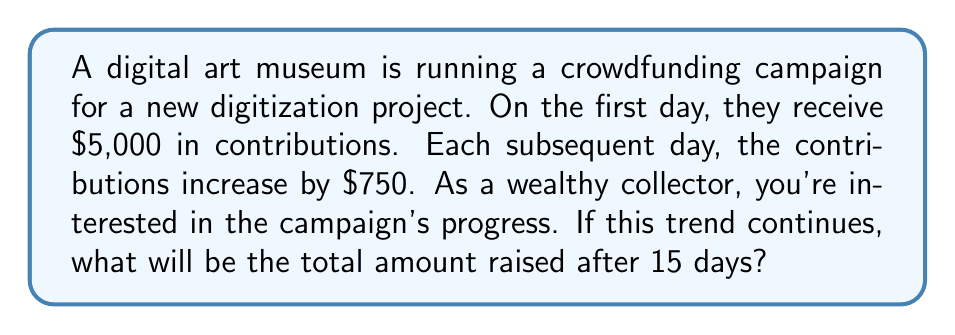Teach me how to tackle this problem. Let's approach this step-by-step using an arithmetic sequence:

1) We have an arithmetic sequence where:
   $a_1 = 5000$ (first term)
   $d = 750$ (common difference)
   $n = 15$ (number of terms)

2) We need to find the sum of this arithmetic sequence. The formula for the sum of an arithmetic sequence is:

   $$S_n = \frac{n}{2}(a_1 + a_n)$$

   Where $a_n$ is the last term.

3) To find $a_n$, we use the formula:
   $$a_n = a_1 + (n-1)d$$
   $$a_{15} = 5000 + (15-1)750 = 5000 + 10500 = 15500$$

4) Now we can calculate the sum:

   $$S_{15} = \frac{15}{2}(5000 + 15500)$$
   $$S_{15} = \frac{15}{2}(20500)$$
   $$S_{15} = 15 \times 10250 = 153750$$

Therefore, the total amount raised after 15 days will be $153,750.
Answer: $153,750 